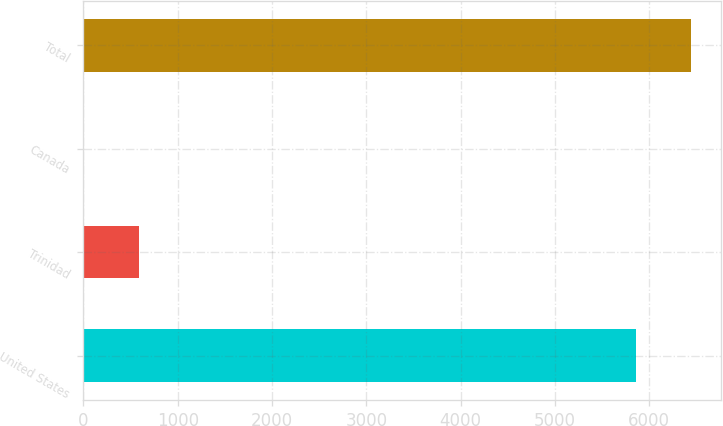Convert chart. <chart><loc_0><loc_0><loc_500><loc_500><bar_chart><fcel>United States<fcel>Trinidad<fcel>Canada<fcel>Total<nl><fcel>5855<fcel>587.8<fcel>1<fcel>6441.8<nl></chart> 